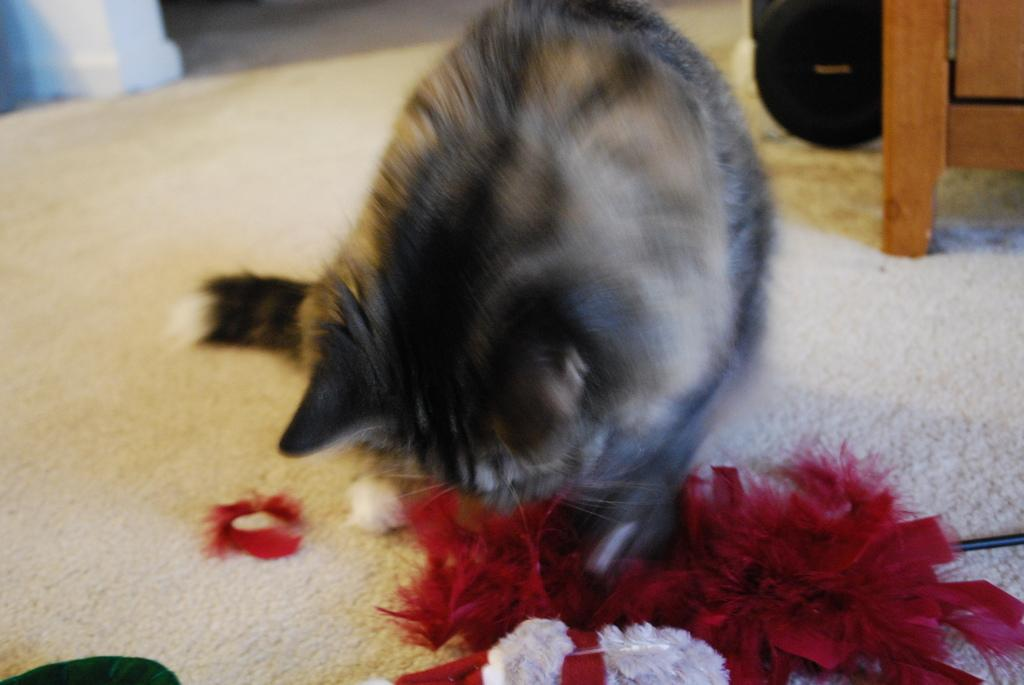What type of animal is in the image? There is a cat in the image. What colors can be seen on the cat? The cat is black and gray in color. What type of flooring is present in the image? There is a carpet in the image. What material is the wooden object made of? The wooden object is made of wood. What is the decoration cloth used for in the image? The decoration cloth is used for decoration purposes in the image. What type of wire is present in the image? There is a cable wire in the image. What type of card is the cat holding in the image? There is no card present in the image; the cat is not holding anything. What type of breakfast is being prepared in the image? There is no breakfast preparation visible in the image. 